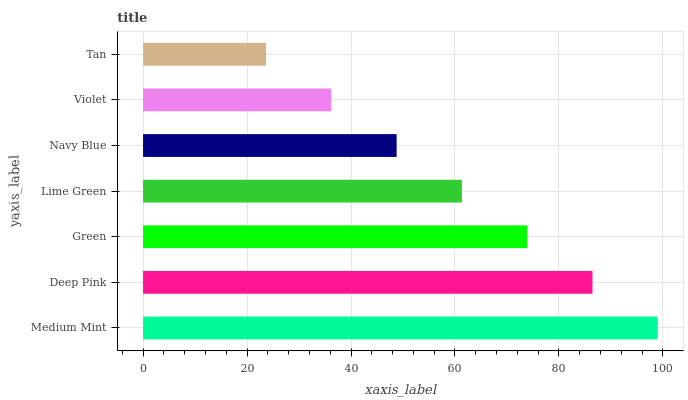Is Tan the minimum?
Answer yes or no. Yes. Is Medium Mint the maximum?
Answer yes or no. Yes. Is Deep Pink the minimum?
Answer yes or no. No. Is Deep Pink the maximum?
Answer yes or no. No. Is Medium Mint greater than Deep Pink?
Answer yes or no. Yes. Is Deep Pink less than Medium Mint?
Answer yes or no. Yes. Is Deep Pink greater than Medium Mint?
Answer yes or no. No. Is Medium Mint less than Deep Pink?
Answer yes or no. No. Is Lime Green the high median?
Answer yes or no. Yes. Is Lime Green the low median?
Answer yes or no. Yes. Is Violet the high median?
Answer yes or no. No. Is Green the low median?
Answer yes or no. No. 